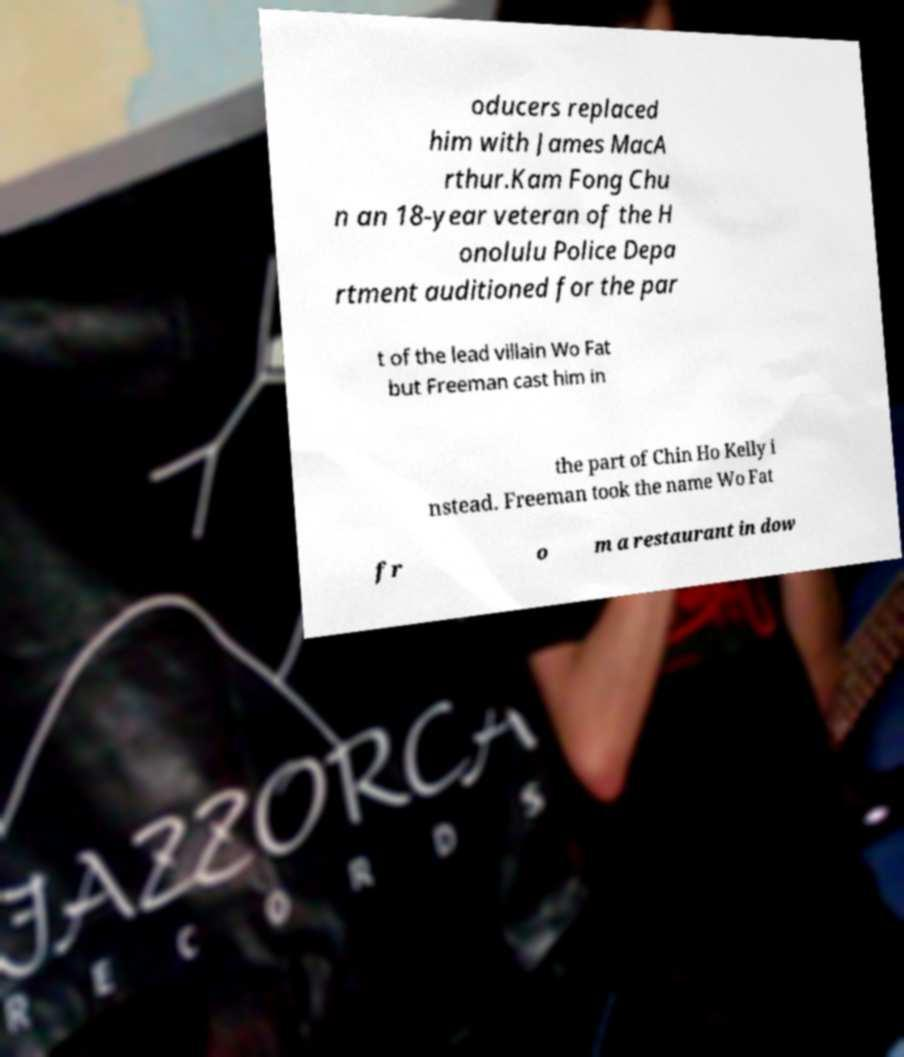For documentation purposes, I need the text within this image transcribed. Could you provide that? oducers replaced him with James MacA rthur.Kam Fong Chu n an 18-year veteran of the H onolulu Police Depa rtment auditioned for the par t of the lead villain Wo Fat but Freeman cast him in the part of Chin Ho Kelly i nstead. Freeman took the name Wo Fat fr o m a restaurant in dow 